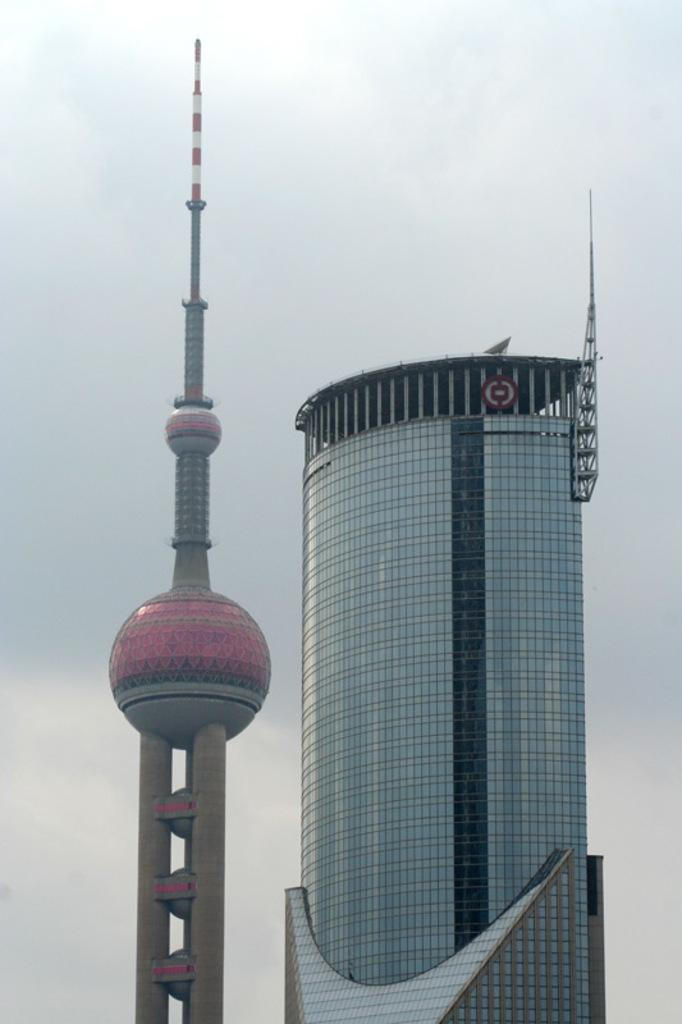What type of building can be seen in the image? There is a glass building in the image. What other structure is present in the image? There is a tower in the image. What can be seen in the background of the image? The sky is visible in the background of the image. How would you describe the weather based on the sky in the image? The sky appears to be cloudy in the image. What type of request can be seen written on the glass building in the image? There is no request visible on the glass building in the image. Is there any beef present in the image? There is no beef present in the image. 